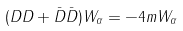<formula> <loc_0><loc_0><loc_500><loc_500>( D D + \bar { D } \bar { D } ) W _ { \alpha } = - 4 m W _ { \alpha }</formula> 